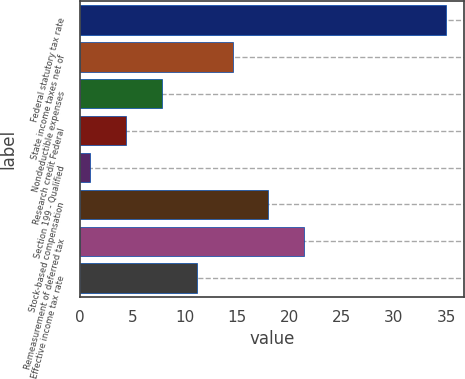Convert chart to OTSL. <chart><loc_0><loc_0><loc_500><loc_500><bar_chart><fcel>Federal statutory tax rate<fcel>State income taxes net of<fcel>Nondeductible expenses<fcel>Research credit Federal<fcel>Section 199 - Qualified<fcel>Stock-based compensation<fcel>Remeasurement of deferred tax<fcel>Effective income tax rate<nl><fcel>35<fcel>14.6<fcel>7.8<fcel>4.4<fcel>1<fcel>18<fcel>21.4<fcel>11.2<nl></chart> 